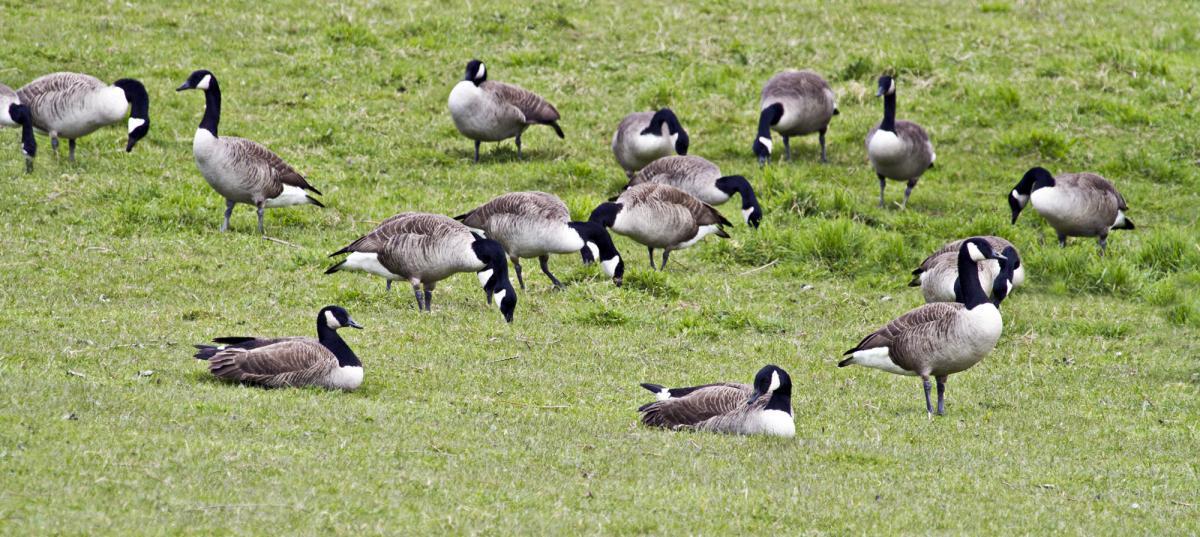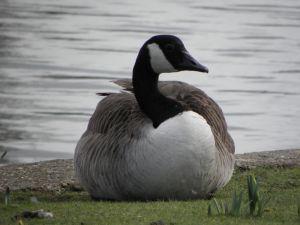The first image is the image on the left, the second image is the image on the right. For the images displayed, is the sentence "Each image shows one goose, and in one image the goose is on water and posed with its neck curved back." factually correct? Answer yes or no. No. The first image is the image on the left, the second image is the image on the right. For the images displayed, is the sentence "The left image contains at least two ducks." factually correct? Answer yes or no. Yes. 